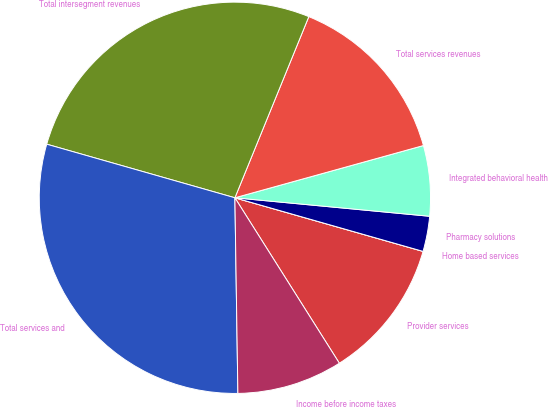Convert chart. <chart><loc_0><loc_0><loc_500><loc_500><pie_chart><fcel>Provider services<fcel>Home based services<fcel>Pharmacy solutions<fcel>Integrated behavioral health<fcel>Total services revenues<fcel>Total intersegment revenues<fcel>Total services and<fcel>Income before income taxes<nl><fcel>11.62%<fcel>0.0%<fcel>2.91%<fcel>5.81%<fcel>14.53%<fcel>26.75%<fcel>29.66%<fcel>8.72%<nl></chart> 